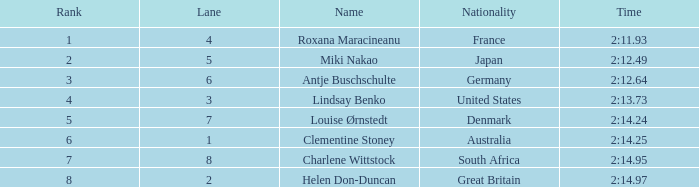How many lanes have a rank above 2 for louise ørnstedt? 1.0. 